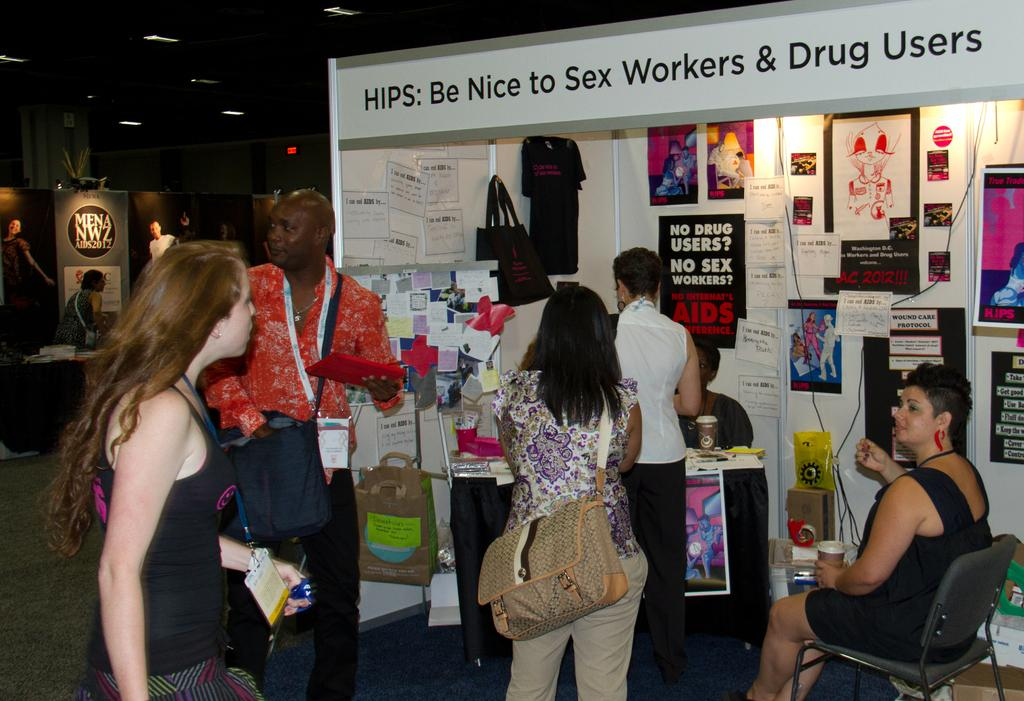What can be seen in the image related to a stall? There are persons in front of the stall. What else is present in the image related to sponsorship? There is a person in front of the sponsor board. Can you describe the lighting in the image? There are lights on the ceiling. What type of caption is written on the fork in the image? There is no fork present in the image, so it is not possible to answer that question. 